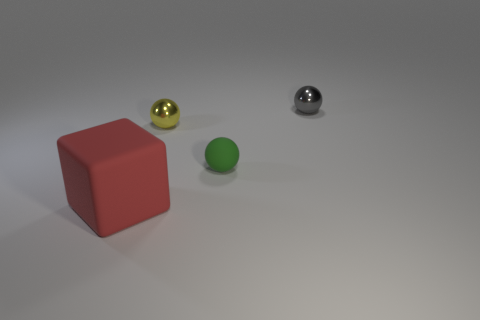Add 4 tiny matte balls. How many objects exist? 8 Subtract all balls. How many objects are left? 1 Add 3 tiny green matte objects. How many tiny green matte objects exist? 4 Subtract 1 green balls. How many objects are left? 3 Subtract all small yellow cylinders. Subtract all tiny green rubber objects. How many objects are left? 3 Add 2 yellow balls. How many yellow balls are left? 3 